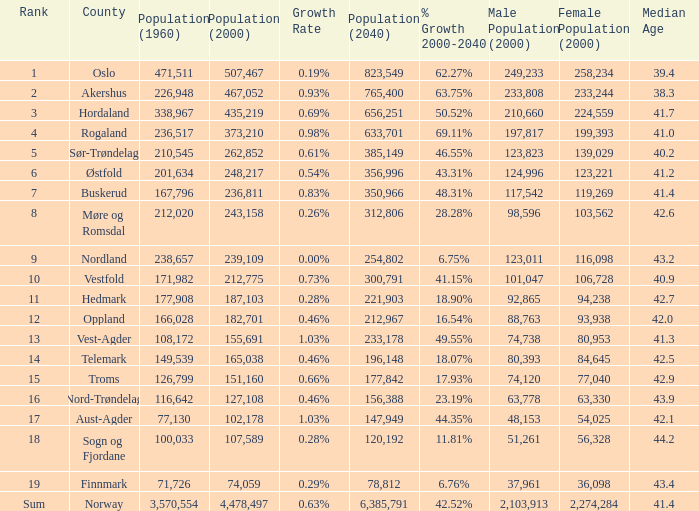What was Oslo's population in 1960, with a population of 507,467 in 2000? None. 